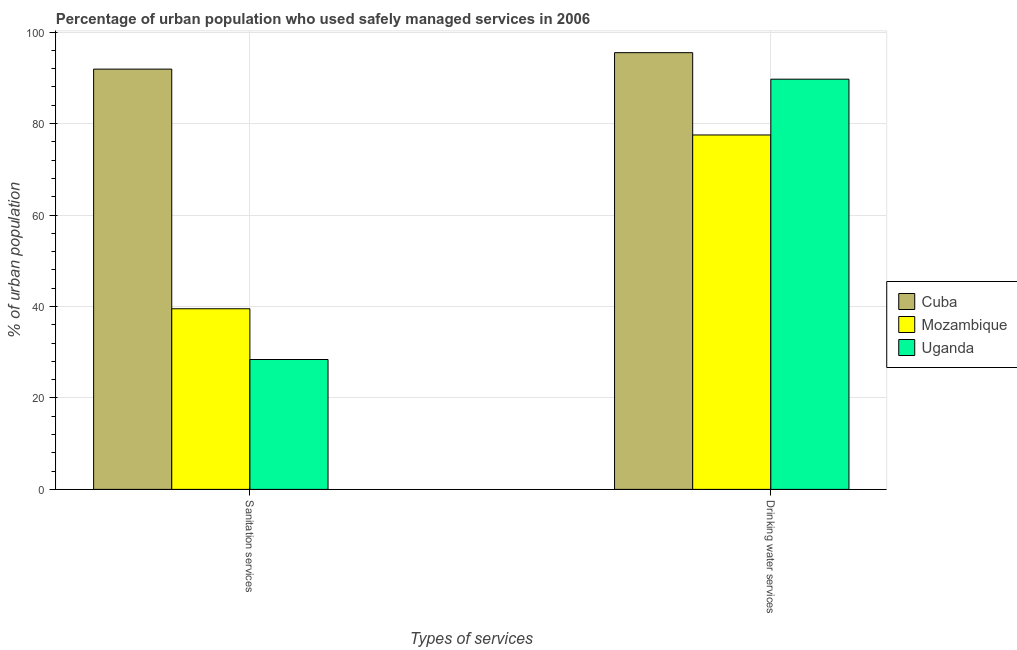How many bars are there on the 2nd tick from the left?
Your answer should be compact. 3. How many bars are there on the 1st tick from the right?
Give a very brief answer. 3. What is the label of the 1st group of bars from the left?
Your response must be concise. Sanitation services. What is the percentage of urban population who used drinking water services in Uganda?
Your answer should be compact. 89.7. Across all countries, what is the maximum percentage of urban population who used sanitation services?
Provide a succinct answer. 91.9. Across all countries, what is the minimum percentage of urban population who used drinking water services?
Your answer should be compact. 77.5. In which country was the percentage of urban population who used drinking water services maximum?
Offer a very short reply. Cuba. In which country was the percentage of urban population who used sanitation services minimum?
Provide a short and direct response. Uganda. What is the total percentage of urban population who used drinking water services in the graph?
Your answer should be compact. 262.7. What is the difference between the percentage of urban population who used sanitation services in Cuba and that in Mozambique?
Ensure brevity in your answer.  52.4. What is the difference between the percentage of urban population who used drinking water services in Cuba and the percentage of urban population who used sanitation services in Mozambique?
Offer a terse response. 56. What is the average percentage of urban population who used sanitation services per country?
Offer a terse response. 53.27. What is the difference between the percentage of urban population who used drinking water services and percentage of urban population who used sanitation services in Mozambique?
Offer a terse response. 38. In how many countries, is the percentage of urban population who used sanitation services greater than 56 %?
Offer a very short reply. 1. What is the ratio of the percentage of urban population who used sanitation services in Mozambique to that in Cuba?
Your response must be concise. 0.43. Is the percentage of urban population who used sanitation services in Mozambique less than that in Cuba?
Ensure brevity in your answer.  Yes. In how many countries, is the percentage of urban population who used sanitation services greater than the average percentage of urban population who used sanitation services taken over all countries?
Make the answer very short. 1. What does the 3rd bar from the left in Sanitation services represents?
Provide a short and direct response. Uganda. What does the 2nd bar from the right in Drinking water services represents?
Your response must be concise. Mozambique. How many bars are there?
Your response must be concise. 6. Are all the bars in the graph horizontal?
Provide a succinct answer. No. How many countries are there in the graph?
Provide a succinct answer. 3. Does the graph contain any zero values?
Provide a succinct answer. No. Does the graph contain grids?
Ensure brevity in your answer.  Yes. How are the legend labels stacked?
Provide a short and direct response. Vertical. What is the title of the graph?
Your answer should be very brief. Percentage of urban population who used safely managed services in 2006. Does "Heavily indebted poor countries" appear as one of the legend labels in the graph?
Ensure brevity in your answer.  No. What is the label or title of the X-axis?
Your response must be concise. Types of services. What is the label or title of the Y-axis?
Ensure brevity in your answer.  % of urban population. What is the % of urban population of Cuba in Sanitation services?
Give a very brief answer. 91.9. What is the % of urban population of Mozambique in Sanitation services?
Your answer should be compact. 39.5. What is the % of urban population of Uganda in Sanitation services?
Keep it short and to the point. 28.4. What is the % of urban population of Cuba in Drinking water services?
Your response must be concise. 95.5. What is the % of urban population in Mozambique in Drinking water services?
Your answer should be very brief. 77.5. What is the % of urban population in Uganda in Drinking water services?
Your response must be concise. 89.7. Across all Types of services, what is the maximum % of urban population of Cuba?
Keep it short and to the point. 95.5. Across all Types of services, what is the maximum % of urban population of Mozambique?
Offer a very short reply. 77.5. Across all Types of services, what is the maximum % of urban population of Uganda?
Your answer should be compact. 89.7. Across all Types of services, what is the minimum % of urban population of Cuba?
Your response must be concise. 91.9. Across all Types of services, what is the minimum % of urban population of Mozambique?
Provide a short and direct response. 39.5. Across all Types of services, what is the minimum % of urban population in Uganda?
Your response must be concise. 28.4. What is the total % of urban population in Cuba in the graph?
Make the answer very short. 187.4. What is the total % of urban population in Mozambique in the graph?
Ensure brevity in your answer.  117. What is the total % of urban population in Uganda in the graph?
Ensure brevity in your answer.  118.1. What is the difference between the % of urban population in Cuba in Sanitation services and that in Drinking water services?
Give a very brief answer. -3.6. What is the difference between the % of urban population in Mozambique in Sanitation services and that in Drinking water services?
Make the answer very short. -38. What is the difference between the % of urban population in Uganda in Sanitation services and that in Drinking water services?
Keep it short and to the point. -61.3. What is the difference between the % of urban population of Cuba in Sanitation services and the % of urban population of Mozambique in Drinking water services?
Provide a short and direct response. 14.4. What is the difference between the % of urban population of Mozambique in Sanitation services and the % of urban population of Uganda in Drinking water services?
Provide a short and direct response. -50.2. What is the average % of urban population of Cuba per Types of services?
Provide a succinct answer. 93.7. What is the average % of urban population of Mozambique per Types of services?
Your answer should be compact. 58.5. What is the average % of urban population in Uganda per Types of services?
Offer a very short reply. 59.05. What is the difference between the % of urban population of Cuba and % of urban population of Mozambique in Sanitation services?
Your response must be concise. 52.4. What is the difference between the % of urban population of Cuba and % of urban population of Uganda in Sanitation services?
Your answer should be compact. 63.5. What is the difference between the % of urban population of Mozambique and % of urban population of Uganda in Sanitation services?
Offer a very short reply. 11.1. What is the difference between the % of urban population of Cuba and % of urban population of Mozambique in Drinking water services?
Your answer should be very brief. 18. What is the difference between the % of urban population of Cuba and % of urban population of Uganda in Drinking water services?
Offer a very short reply. 5.8. What is the ratio of the % of urban population in Cuba in Sanitation services to that in Drinking water services?
Your response must be concise. 0.96. What is the ratio of the % of urban population in Mozambique in Sanitation services to that in Drinking water services?
Give a very brief answer. 0.51. What is the ratio of the % of urban population in Uganda in Sanitation services to that in Drinking water services?
Your response must be concise. 0.32. What is the difference between the highest and the second highest % of urban population of Uganda?
Make the answer very short. 61.3. What is the difference between the highest and the lowest % of urban population in Cuba?
Your answer should be very brief. 3.6. What is the difference between the highest and the lowest % of urban population of Mozambique?
Ensure brevity in your answer.  38. What is the difference between the highest and the lowest % of urban population in Uganda?
Provide a short and direct response. 61.3. 